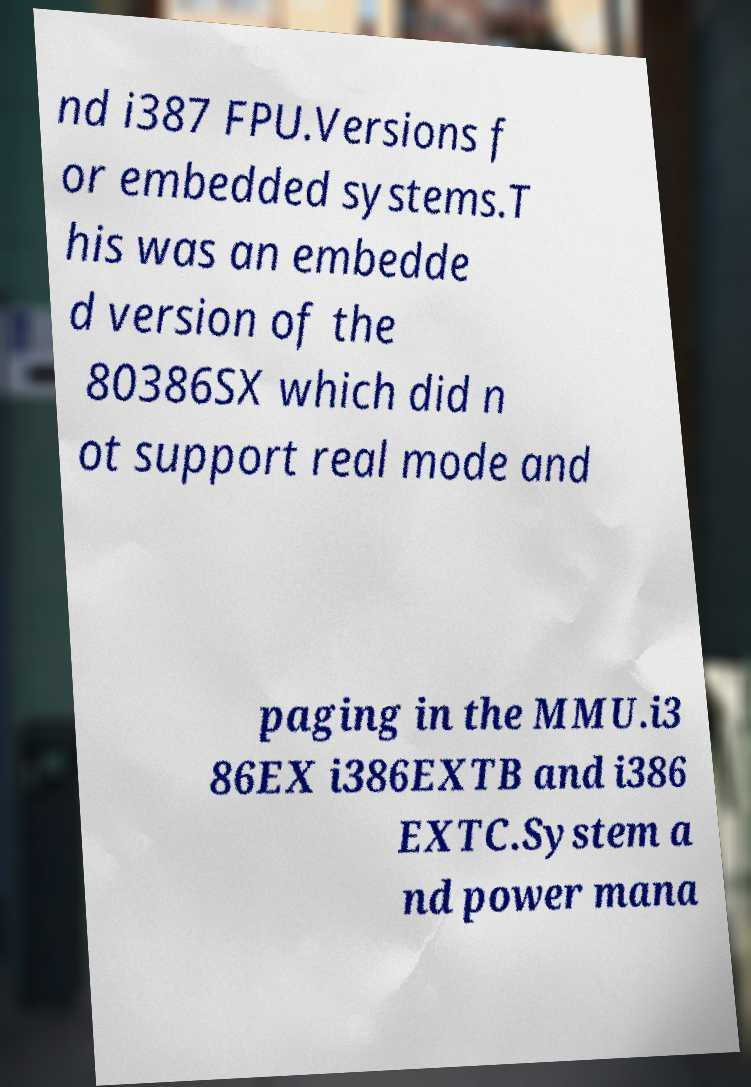Could you assist in decoding the text presented in this image and type it out clearly? nd i387 FPU.Versions f or embedded systems.T his was an embedde d version of the 80386SX which did n ot support real mode and paging in the MMU.i3 86EX i386EXTB and i386 EXTC.System a nd power mana 